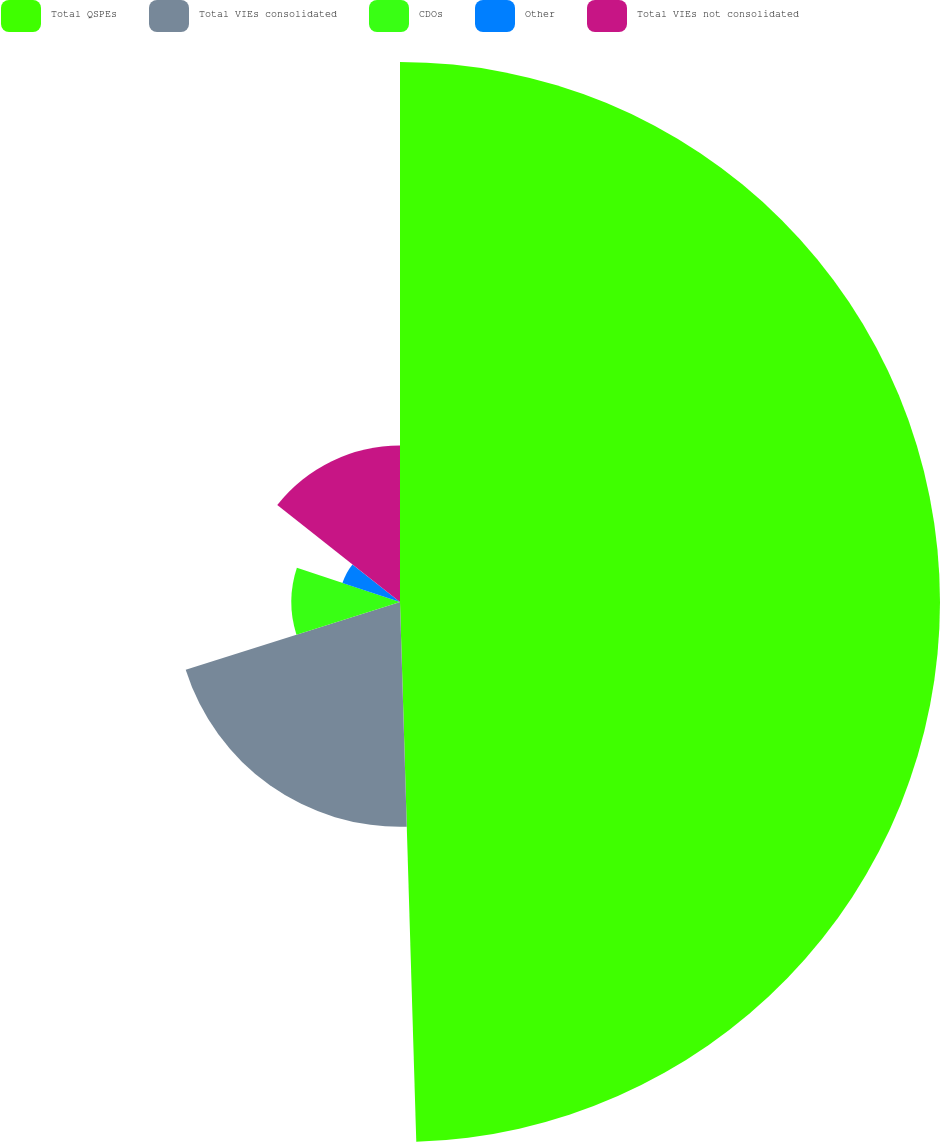<chart> <loc_0><loc_0><loc_500><loc_500><pie_chart><fcel>Total QSPEs<fcel>Total VIEs consolidated<fcel>CDOs<fcel>Other<fcel>Total VIEs not consolidated<nl><fcel>49.52%<fcel>20.61%<fcel>9.96%<fcel>5.56%<fcel>14.35%<nl></chart> 